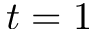<formula> <loc_0><loc_0><loc_500><loc_500>t = 1</formula> 